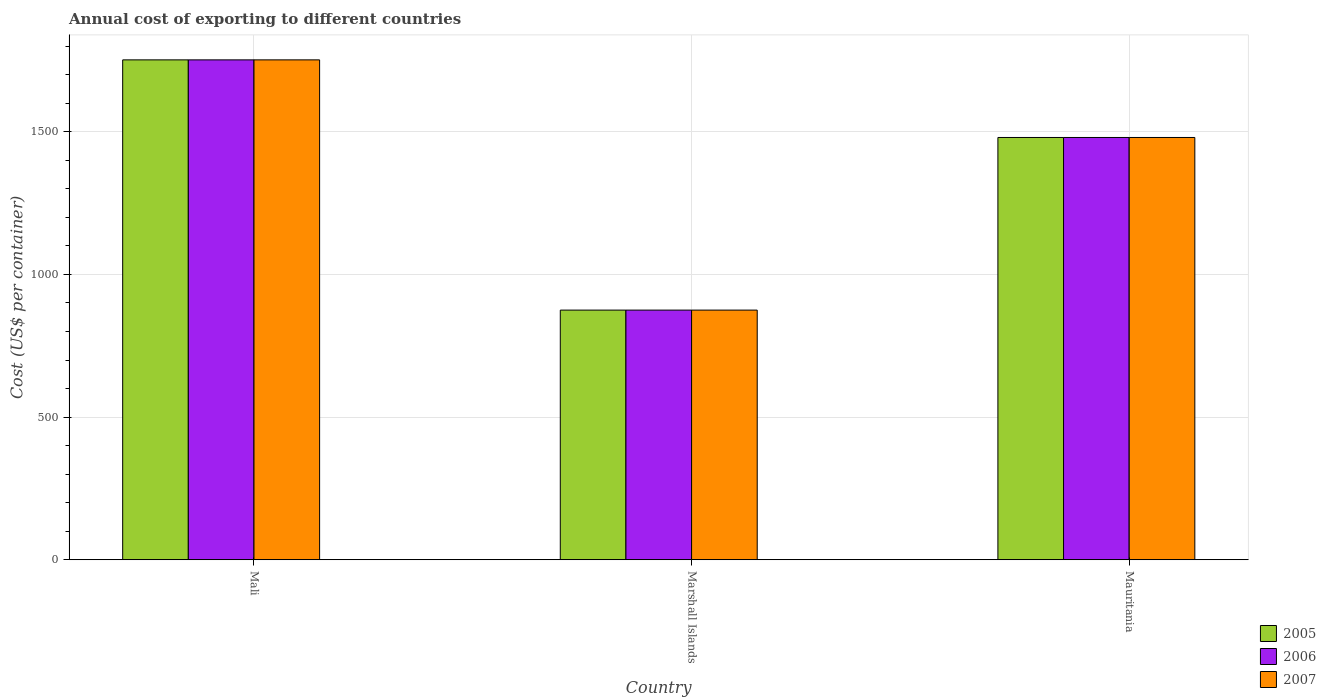How many different coloured bars are there?
Offer a terse response. 3. Are the number of bars per tick equal to the number of legend labels?
Keep it short and to the point. Yes. Are the number of bars on each tick of the X-axis equal?
Your answer should be compact. Yes. How many bars are there on the 3rd tick from the right?
Offer a terse response. 3. What is the label of the 1st group of bars from the left?
Give a very brief answer. Mali. In how many cases, is the number of bars for a given country not equal to the number of legend labels?
Offer a terse response. 0. What is the total annual cost of exporting in 2005 in Marshall Islands?
Offer a very short reply. 875. Across all countries, what is the maximum total annual cost of exporting in 2005?
Provide a short and direct response. 1752. Across all countries, what is the minimum total annual cost of exporting in 2006?
Provide a succinct answer. 875. In which country was the total annual cost of exporting in 2005 maximum?
Your response must be concise. Mali. In which country was the total annual cost of exporting in 2007 minimum?
Offer a very short reply. Marshall Islands. What is the total total annual cost of exporting in 2007 in the graph?
Your response must be concise. 4107. What is the difference between the total annual cost of exporting in 2005 in Mali and that in Mauritania?
Your answer should be very brief. 272. What is the difference between the total annual cost of exporting in 2007 in Mali and the total annual cost of exporting in 2005 in Marshall Islands?
Keep it short and to the point. 877. What is the average total annual cost of exporting in 2007 per country?
Provide a short and direct response. 1369. What is the difference between the total annual cost of exporting of/in 2005 and total annual cost of exporting of/in 2007 in Mauritania?
Your answer should be very brief. 0. In how many countries, is the total annual cost of exporting in 2005 greater than 1400 US$?
Make the answer very short. 2. What is the ratio of the total annual cost of exporting in 2005 in Marshall Islands to that in Mauritania?
Make the answer very short. 0.59. Is the total annual cost of exporting in 2006 in Mali less than that in Marshall Islands?
Ensure brevity in your answer.  No. Is the difference between the total annual cost of exporting in 2005 in Mali and Marshall Islands greater than the difference between the total annual cost of exporting in 2007 in Mali and Marshall Islands?
Ensure brevity in your answer.  No. What is the difference between the highest and the second highest total annual cost of exporting in 2006?
Provide a succinct answer. 877. What is the difference between the highest and the lowest total annual cost of exporting in 2006?
Keep it short and to the point. 877. Is the sum of the total annual cost of exporting in 2006 in Mali and Mauritania greater than the maximum total annual cost of exporting in 2007 across all countries?
Provide a short and direct response. Yes. What does the 2nd bar from the left in Marshall Islands represents?
Give a very brief answer. 2006. What does the 2nd bar from the right in Mauritania represents?
Provide a short and direct response. 2006. How many bars are there?
Make the answer very short. 9. Does the graph contain grids?
Your answer should be very brief. Yes. What is the title of the graph?
Provide a succinct answer. Annual cost of exporting to different countries. What is the label or title of the X-axis?
Provide a short and direct response. Country. What is the label or title of the Y-axis?
Your answer should be very brief. Cost (US$ per container). What is the Cost (US$ per container) in 2005 in Mali?
Ensure brevity in your answer.  1752. What is the Cost (US$ per container) of 2006 in Mali?
Make the answer very short. 1752. What is the Cost (US$ per container) in 2007 in Mali?
Provide a short and direct response. 1752. What is the Cost (US$ per container) of 2005 in Marshall Islands?
Make the answer very short. 875. What is the Cost (US$ per container) in 2006 in Marshall Islands?
Provide a succinct answer. 875. What is the Cost (US$ per container) in 2007 in Marshall Islands?
Provide a short and direct response. 875. What is the Cost (US$ per container) of 2005 in Mauritania?
Your answer should be very brief. 1480. What is the Cost (US$ per container) in 2006 in Mauritania?
Provide a short and direct response. 1480. What is the Cost (US$ per container) in 2007 in Mauritania?
Keep it short and to the point. 1480. Across all countries, what is the maximum Cost (US$ per container) in 2005?
Your response must be concise. 1752. Across all countries, what is the maximum Cost (US$ per container) in 2006?
Ensure brevity in your answer.  1752. Across all countries, what is the maximum Cost (US$ per container) of 2007?
Make the answer very short. 1752. Across all countries, what is the minimum Cost (US$ per container) of 2005?
Your response must be concise. 875. Across all countries, what is the minimum Cost (US$ per container) of 2006?
Provide a short and direct response. 875. Across all countries, what is the minimum Cost (US$ per container) in 2007?
Provide a succinct answer. 875. What is the total Cost (US$ per container) in 2005 in the graph?
Offer a very short reply. 4107. What is the total Cost (US$ per container) of 2006 in the graph?
Provide a succinct answer. 4107. What is the total Cost (US$ per container) in 2007 in the graph?
Offer a very short reply. 4107. What is the difference between the Cost (US$ per container) in 2005 in Mali and that in Marshall Islands?
Your response must be concise. 877. What is the difference between the Cost (US$ per container) in 2006 in Mali and that in Marshall Islands?
Ensure brevity in your answer.  877. What is the difference between the Cost (US$ per container) in 2007 in Mali and that in Marshall Islands?
Give a very brief answer. 877. What is the difference between the Cost (US$ per container) of 2005 in Mali and that in Mauritania?
Your response must be concise. 272. What is the difference between the Cost (US$ per container) in 2006 in Mali and that in Mauritania?
Your answer should be very brief. 272. What is the difference between the Cost (US$ per container) in 2007 in Mali and that in Mauritania?
Your response must be concise. 272. What is the difference between the Cost (US$ per container) in 2005 in Marshall Islands and that in Mauritania?
Provide a succinct answer. -605. What is the difference between the Cost (US$ per container) of 2006 in Marshall Islands and that in Mauritania?
Provide a short and direct response. -605. What is the difference between the Cost (US$ per container) in 2007 in Marshall Islands and that in Mauritania?
Your response must be concise. -605. What is the difference between the Cost (US$ per container) in 2005 in Mali and the Cost (US$ per container) in 2006 in Marshall Islands?
Provide a short and direct response. 877. What is the difference between the Cost (US$ per container) in 2005 in Mali and the Cost (US$ per container) in 2007 in Marshall Islands?
Provide a short and direct response. 877. What is the difference between the Cost (US$ per container) of 2006 in Mali and the Cost (US$ per container) of 2007 in Marshall Islands?
Provide a succinct answer. 877. What is the difference between the Cost (US$ per container) in 2005 in Mali and the Cost (US$ per container) in 2006 in Mauritania?
Give a very brief answer. 272. What is the difference between the Cost (US$ per container) in 2005 in Mali and the Cost (US$ per container) in 2007 in Mauritania?
Make the answer very short. 272. What is the difference between the Cost (US$ per container) in 2006 in Mali and the Cost (US$ per container) in 2007 in Mauritania?
Your answer should be compact. 272. What is the difference between the Cost (US$ per container) in 2005 in Marshall Islands and the Cost (US$ per container) in 2006 in Mauritania?
Your response must be concise. -605. What is the difference between the Cost (US$ per container) of 2005 in Marshall Islands and the Cost (US$ per container) of 2007 in Mauritania?
Provide a succinct answer. -605. What is the difference between the Cost (US$ per container) of 2006 in Marshall Islands and the Cost (US$ per container) of 2007 in Mauritania?
Give a very brief answer. -605. What is the average Cost (US$ per container) in 2005 per country?
Keep it short and to the point. 1369. What is the average Cost (US$ per container) in 2006 per country?
Offer a very short reply. 1369. What is the average Cost (US$ per container) in 2007 per country?
Your response must be concise. 1369. What is the difference between the Cost (US$ per container) of 2006 and Cost (US$ per container) of 2007 in Mali?
Offer a very short reply. 0. What is the difference between the Cost (US$ per container) in 2005 and Cost (US$ per container) in 2006 in Marshall Islands?
Offer a very short reply. 0. What is the difference between the Cost (US$ per container) in 2006 and Cost (US$ per container) in 2007 in Marshall Islands?
Make the answer very short. 0. What is the difference between the Cost (US$ per container) of 2005 and Cost (US$ per container) of 2006 in Mauritania?
Your response must be concise. 0. What is the difference between the Cost (US$ per container) in 2005 and Cost (US$ per container) in 2007 in Mauritania?
Ensure brevity in your answer.  0. What is the difference between the Cost (US$ per container) of 2006 and Cost (US$ per container) of 2007 in Mauritania?
Offer a very short reply. 0. What is the ratio of the Cost (US$ per container) of 2005 in Mali to that in Marshall Islands?
Make the answer very short. 2. What is the ratio of the Cost (US$ per container) in 2006 in Mali to that in Marshall Islands?
Your answer should be compact. 2. What is the ratio of the Cost (US$ per container) in 2007 in Mali to that in Marshall Islands?
Your answer should be compact. 2. What is the ratio of the Cost (US$ per container) in 2005 in Mali to that in Mauritania?
Offer a terse response. 1.18. What is the ratio of the Cost (US$ per container) in 2006 in Mali to that in Mauritania?
Offer a terse response. 1.18. What is the ratio of the Cost (US$ per container) in 2007 in Mali to that in Mauritania?
Provide a succinct answer. 1.18. What is the ratio of the Cost (US$ per container) of 2005 in Marshall Islands to that in Mauritania?
Keep it short and to the point. 0.59. What is the ratio of the Cost (US$ per container) in 2006 in Marshall Islands to that in Mauritania?
Ensure brevity in your answer.  0.59. What is the ratio of the Cost (US$ per container) in 2007 in Marshall Islands to that in Mauritania?
Offer a very short reply. 0.59. What is the difference between the highest and the second highest Cost (US$ per container) of 2005?
Your answer should be very brief. 272. What is the difference between the highest and the second highest Cost (US$ per container) of 2006?
Keep it short and to the point. 272. What is the difference between the highest and the second highest Cost (US$ per container) of 2007?
Ensure brevity in your answer.  272. What is the difference between the highest and the lowest Cost (US$ per container) in 2005?
Give a very brief answer. 877. What is the difference between the highest and the lowest Cost (US$ per container) in 2006?
Your answer should be very brief. 877. What is the difference between the highest and the lowest Cost (US$ per container) of 2007?
Give a very brief answer. 877. 